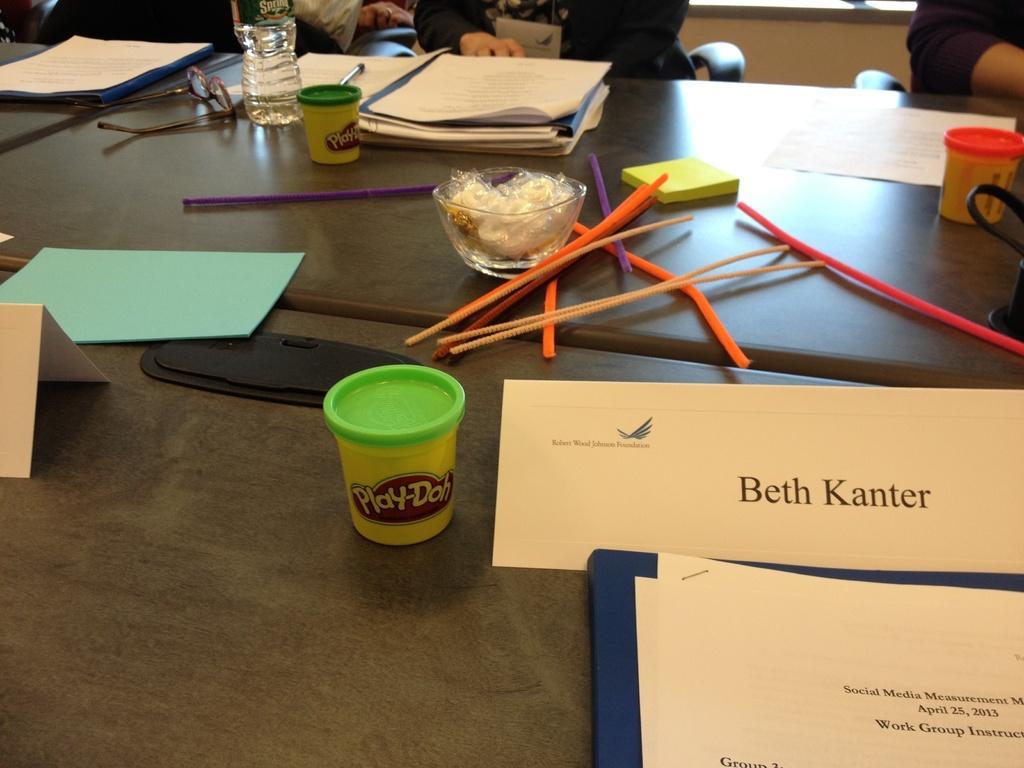Describe this image in one or two sentences. In the image there are files,books,water bottle,glasses,sticks on the table with some persons sitting on it on the chairs. 